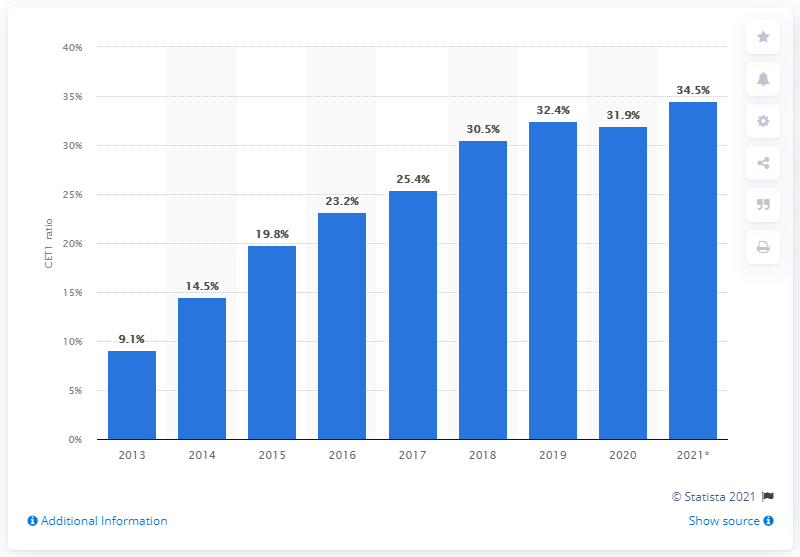Point out several critical features in this image. The Common Equity Tier 1 (CET1) ratio was 32.4 between 2013 and 2018. The Common Equity Tier 1 (CET1) ratio in 2021 was 34.5%. 